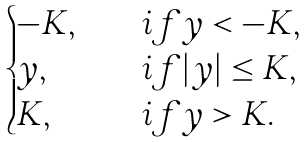Convert formula to latex. <formula><loc_0><loc_0><loc_500><loc_500>\begin{cases} - K , & \quad i f y < - K , \\ y , & \quad i f | y | \leq K , \\ K , & \quad i f y > K . \end{cases}</formula> 